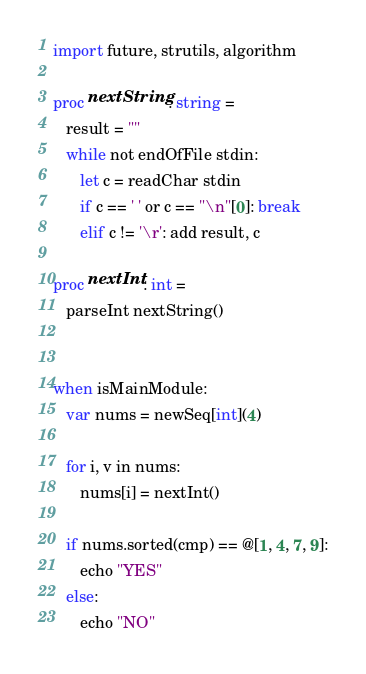Convert code to text. <code><loc_0><loc_0><loc_500><loc_500><_Nim_>import future, strutils, algorithm

proc nextString: string =
   result = ""
   while not endOfFile stdin:
      let c = readChar stdin
      if c == ' ' or c == "\n"[0]: break
      elif c != '\r': add result, c

proc nextInt: int =
   parseInt nextString()


when isMainModule:
   var nums = newSeq[int](4)

   for i, v in nums:
      nums[i] = nextInt()

   if nums.sorted(cmp) == @[1, 4, 7, 9]:
      echo "YES"
   else:
      echo "NO"
</code> 